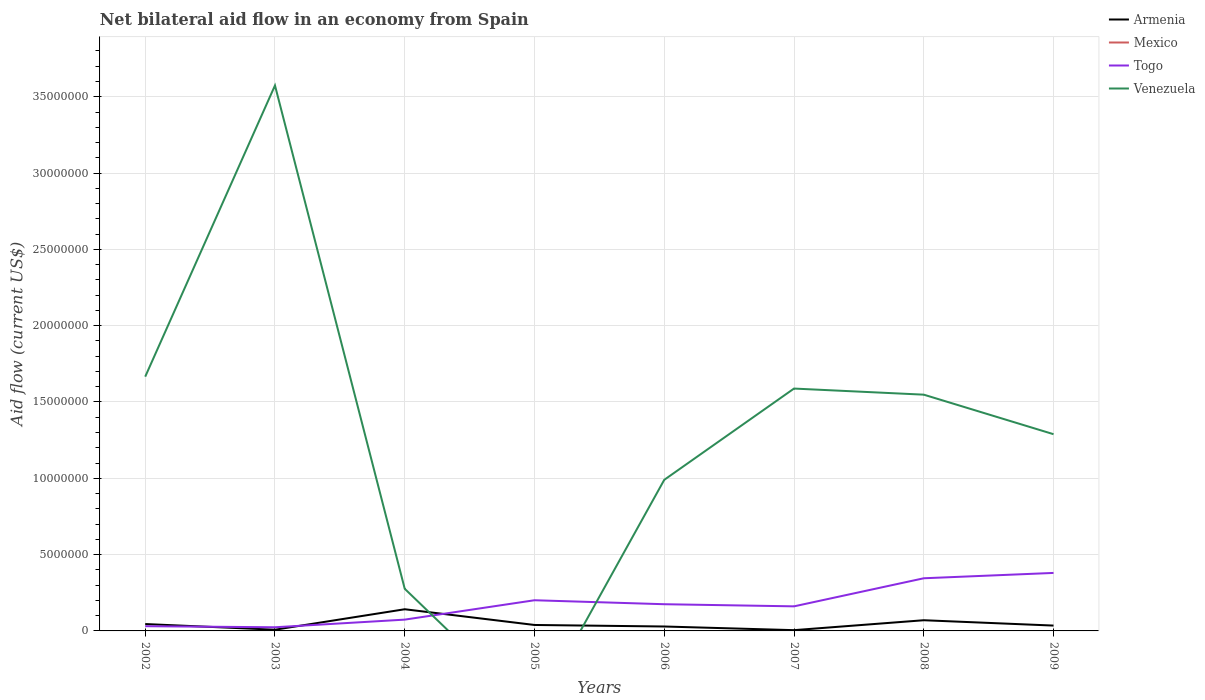Does the line corresponding to Togo intersect with the line corresponding to Venezuela?
Provide a short and direct response. Yes. Is the number of lines equal to the number of legend labels?
Offer a terse response. No. What is the total net bilateral aid flow in Togo in the graph?
Your answer should be compact. -2.71e+06. What is the difference between the highest and the second highest net bilateral aid flow in Armenia?
Ensure brevity in your answer.  1.37e+06. What is the difference between the highest and the lowest net bilateral aid flow in Togo?
Your response must be concise. 4. What is the difference between two consecutive major ticks on the Y-axis?
Provide a short and direct response. 5.00e+06. Where does the legend appear in the graph?
Your answer should be very brief. Top right. How many legend labels are there?
Offer a terse response. 4. How are the legend labels stacked?
Provide a short and direct response. Vertical. What is the title of the graph?
Offer a very short reply. Net bilateral aid flow in an economy from Spain. What is the label or title of the X-axis?
Give a very brief answer. Years. What is the label or title of the Y-axis?
Your answer should be compact. Aid flow (current US$). What is the Aid flow (current US$) in Armenia in 2002?
Make the answer very short. 4.50e+05. What is the Aid flow (current US$) of Mexico in 2002?
Offer a terse response. 0. What is the Aid flow (current US$) of Togo in 2002?
Provide a succinct answer. 3.10e+05. What is the Aid flow (current US$) of Venezuela in 2002?
Provide a short and direct response. 1.67e+07. What is the Aid flow (current US$) of Venezuela in 2003?
Offer a very short reply. 3.57e+07. What is the Aid flow (current US$) of Armenia in 2004?
Provide a succinct answer. 1.42e+06. What is the Aid flow (current US$) in Togo in 2004?
Provide a succinct answer. 7.40e+05. What is the Aid flow (current US$) of Venezuela in 2004?
Provide a succinct answer. 2.76e+06. What is the Aid flow (current US$) in Togo in 2005?
Provide a succinct answer. 2.01e+06. What is the Aid flow (current US$) of Venezuela in 2005?
Your answer should be very brief. 0. What is the Aid flow (current US$) in Armenia in 2006?
Provide a succinct answer. 2.90e+05. What is the Aid flow (current US$) in Togo in 2006?
Ensure brevity in your answer.  1.75e+06. What is the Aid flow (current US$) in Venezuela in 2006?
Your answer should be very brief. 9.90e+06. What is the Aid flow (current US$) of Armenia in 2007?
Keep it short and to the point. 5.00e+04. What is the Aid flow (current US$) of Mexico in 2007?
Your answer should be very brief. 0. What is the Aid flow (current US$) of Togo in 2007?
Provide a short and direct response. 1.61e+06. What is the Aid flow (current US$) of Venezuela in 2007?
Provide a succinct answer. 1.59e+07. What is the Aid flow (current US$) of Armenia in 2008?
Give a very brief answer. 7.00e+05. What is the Aid flow (current US$) of Togo in 2008?
Your response must be concise. 3.45e+06. What is the Aid flow (current US$) of Venezuela in 2008?
Keep it short and to the point. 1.55e+07. What is the Aid flow (current US$) in Armenia in 2009?
Provide a succinct answer. 3.50e+05. What is the Aid flow (current US$) of Mexico in 2009?
Your response must be concise. 0. What is the Aid flow (current US$) in Togo in 2009?
Keep it short and to the point. 3.80e+06. What is the Aid flow (current US$) of Venezuela in 2009?
Make the answer very short. 1.29e+07. Across all years, what is the maximum Aid flow (current US$) in Armenia?
Provide a short and direct response. 1.42e+06. Across all years, what is the maximum Aid flow (current US$) in Togo?
Your response must be concise. 3.80e+06. Across all years, what is the maximum Aid flow (current US$) in Venezuela?
Ensure brevity in your answer.  3.57e+07. Across all years, what is the minimum Aid flow (current US$) of Armenia?
Give a very brief answer. 5.00e+04. Across all years, what is the minimum Aid flow (current US$) of Togo?
Keep it short and to the point. 2.40e+05. What is the total Aid flow (current US$) of Armenia in the graph?
Provide a short and direct response. 3.73e+06. What is the total Aid flow (current US$) of Togo in the graph?
Ensure brevity in your answer.  1.39e+07. What is the total Aid flow (current US$) in Venezuela in the graph?
Your response must be concise. 1.09e+08. What is the difference between the Aid flow (current US$) in Armenia in 2002 and that in 2003?
Your answer should be compact. 3.70e+05. What is the difference between the Aid flow (current US$) of Venezuela in 2002 and that in 2003?
Your response must be concise. -1.91e+07. What is the difference between the Aid flow (current US$) of Armenia in 2002 and that in 2004?
Ensure brevity in your answer.  -9.70e+05. What is the difference between the Aid flow (current US$) of Togo in 2002 and that in 2004?
Provide a short and direct response. -4.30e+05. What is the difference between the Aid flow (current US$) of Venezuela in 2002 and that in 2004?
Give a very brief answer. 1.39e+07. What is the difference between the Aid flow (current US$) in Armenia in 2002 and that in 2005?
Offer a very short reply. 6.00e+04. What is the difference between the Aid flow (current US$) in Togo in 2002 and that in 2005?
Make the answer very short. -1.70e+06. What is the difference between the Aid flow (current US$) in Armenia in 2002 and that in 2006?
Your response must be concise. 1.60e+05. What is the difference between the Aid flow (current US$) of Togo in 2002 and that in 2006?
Ensure brevity in your answer.  -1.44e+06. What is the difference between the Aid flow (current US$) of Venezuela in 2002 and that in 2006?
Make the answer very short. 6.76e+06. What is the difference between the Aid flow (current US$) in Armenia in 2002 and that in 2007?
Provide a succinct answer. 4.00e+05. What is the difference between the Aid flow (current US$) of Togo in 2002 and that in 2007?
Provide a short and direct response. -1.30e+06. What is the difference between the Aid flow (current US$) of Venezuela in 2002 and that in 2007?
Offer a terse response. 7.80e+05. What is the difference between the Aid flow (current US$) of Armenia in 2002 and that in 2008?
Your answer should be very brief. -2.50e+05. What is the difference between the Aid flow (current US$) in Togo in 2002 and that in 2008?
Your answer should be very brief. -3.14e+06. What is the difference between the Aid flow (current US$) in Venezuela in 2002 and that in 2008?
Offer a terse response. 1.18e+06. What is the difference between the Aid flow (current US$) of Togo in 2002 and that in 2009?
Your answer should be compact. -3.49e+06. What is the difference between the Aid flow (current US$) of Venezuela in 2002 and that in 2009?
Provide a succinct answer. 3.77e+06. What is the difference between the Aid flow (current US$) in Armenia in 2003 and that in 2004?
Your answer should be very brief. -1.34e+06. What is the difference between the Aid flow (current US$) in Togo in 2003 and that in 2004?
Your answer should be very brief. -5.00e+05. What is the difference between the Aid flow (current US$) of Venezuela in 2003 and that in 2004?
Your response must be concise. 3.30e+07. What is the difference between the Aid flow (current US$) in Armenia in 2003 and that in 2005?
Offer a very short reply. -3.10e+05. What is the difference between the Aid flow (current US$) in Togo in 2003 and that in 2005?
Ensure brevity in your answer.  -1.77e+06. What is the difference between the Aid flow (current US$) in Togo in 2003 and that in 2006?
Your response must be concise. -1.51e+06. What is the difference between the Aid flow (current US$) in Venezuela in 2003 and that in 2006?
Your answer should be very brief. 2.58e+07. What is the difference between the Aid flow (current US$) in Togo in 2003 and that in 2007?
Your answer should be compact. -1.37e+06. What is the difference between the Aid flow (current US$) of Venezuela in 2003 and that in 2007?
Provide a short and direct response. 1.99e+07. What is the difference between the Aid flow (current US$) of Armenia in 2003 and that in 2008?
Your answer should be very brief. -6.20e+05. What is the difference between the Aid flow (current US$) of Togo in 2003 and that in 2008?
Give a very brief answer. -3.21e+06. What is the difference between the Aid flow (current US$) of Venezuela in 2003 and that in 2008?
Your answer should be very brief. 2.03e+07. What is the difference between the Aid flow (current US$) of Togo in 2003 and that in 2009?
Offer a terse response. -3.56e+06. What is the difference between the Aid flow (current US$) of Venezuela in 2003 and that in 2009?
Offer a terse response. 2.28e+07. What is the difference between the Aid flow (current US$) in Armenia in 2004 and that in 2005?
Your answer should be compact. 1.03e+06. What is the difference between the Aid flow (current US$) of Togo in 2004 and that in 2005?
Ensure brevity in your answer.  -1.27e+06. What is the difference between the Aid flow (current US$) of Armenia in 2004 and that in 2006?
Provide a succinct answer. 1.13e+06. What is the difference between the Aid flow (current US$) of Togo in 2004 and that in 2006?
Give a very brief answer. -1.01e+06. What is the difference between the Aid flow (current US$) in Venezuela in 2004 and that in 2006?
Make the answer very short. -7.14e+06. What is the difference between the Aid flow (current US$) of Armenia in 2004 and that in 2007?
Give a very brief answer. 1.37e+06. What is the difference between the Aid flow (current US$) in Togo in 2004 and that in 2007?
Provide a short and direct response. -8.70e+05. What is the difference between the Aid flow (current US$) in Venezuela in 2004 and that in 2007?
Your answer should be very brief. -1.31e+07. What is the difference between the Aid flow (current US$) in Armenia in 2004 and that in 2008?
Provide a succinct answer. 7.20e+05. What is the difference between the Aid flow (current US$) in Togo in 2004 and that in 2008?
Provide a succinct answer. -2.71e+06. What is the difference between the Aid flow (current US$) of Venezuela in 2004 and that in 2008?
Provide a succinct answer. -1.27e+07. What is the difference between the Aid flow (current US$) in Armenia in 2004 and that in 2009?
Offer a very short reply. 1.07e+06. What is the difference between the Aid flow (current US$) in Togo in 2004 and that in 2009?
Your answer should be compact. -3.06e+06. What is the difference between the Aid flow (current US$) of Venezuela in 2004 and that in 2009?
Keep it short and to the point. -1.01e+07. What is the difference between the Aid flow (current US$) in Togo in 2005 and that in 2006?
Give a very brief answer. 2.60e+05. What is the difference between the Aid flow (current US$) in Armenia in 2005 and that in 2007?
Your response must be concise. 3.40e+05. What is the difference between the Aid flow (current US$) in Armenia in 2005 and that in 2008?
Ensure brevity in your answer.  -3.10e+05. What is the difference between the Aid flow (current US$) in Togo in 2005 and that in 2008?
Offer a terse response. -1.44e+06. What is the difference between the Aid flow (current US$) of Togo in 2005 and that in 2009?
Your answer should be compact. -1.79e+06. What is the difference between the Aid flow (current US$) of Armenia in 2006 and that in 2007?
Offer a terse response. 2.40e+05. What is the difference between the Aid flow (current US$) in Venezuela in 2006 and that in 2007?
Provide a succinct answer. -5.98e+06. What is the difference between the Aid flow (current US$) in Armenia in 2006 and that in 2008?
Provide a short and direct response. -4.10e+05. What is the difference between the Aid flow (current US$) in Togo in 2006 and that in 2008?
Provide a succinct answer. -1.70e+06. What is the difference between the Aid flow (current US$) in Venezuela in 2006 and that in 2008?
Offer a terse response. -5.58e+06. What is the difference between the Aid flow (current US$) in Togo in 2006 and that in 2009?
Offer a very short reply. -2.05e+06. What is the difference between the Aid flow (current US$) in Venezuela in 2006 and that in 2009?
Make the answer very short. -2.99e+06. What is the difference between the Aid flow (current US$) in Armenia in 2007 and that in 2008?
Offer a very short reply. -6.50e+05. What is the difference between the Aid flow (current US$) in Togo in 2007 and that in 2008?
Your answer should be compact. -1.84e+06. What is the difference between the Aid flow (current US$) in Venezuela in 2007 and that in 2008?
Your answer should be compact. 4.00e+05. What is the difference between the Aid flow (current US$) of Armenia in 2007 and that in 2009?
Ensure brevity in your answer.  -3.00e+05. What is the difference between the Aid flow (current US$) of Togo in 2007 and that in 2009?
Your response must be concise. -2.19e+06. What is the difference between the Aid flow (current US$) of Venezuela in 2007 and that in 2009?
Your response must be concise. 2.99e+06. What is the difference between the Aid flow (current US$) in Togo in 2008 and that in 2009?
Ensure brevity in your answer.  -3.50e+05. What is the difference between the Aid flow (current US$) of Venezuela in 2008 and that in 2009?
Your answer should be compact. 2.59e+06. What is the difference between the Aid flow (current US$) of Armenia in 2002 and the Aid flow (current US$) of Venezuela in 2003?
Your answer should be compact. -3.53e+07. What is the difference between the Aid flow (current US$) in Togo in 2002 and the Aid flow (current US$) in Venezuela in 2003?
Keep it short and to the point. -3.54e+07. What is the difference between the Aid flow (current US$) in Armenia in 2002 and the Aid flow (current US$) in Venezuela in 2004?
Provide a short and direct response. -2.31e+06. What is the difference between the Aid flow (current US$) of Togo in 2002 and the Aid flow (current US$) of Venezuela in 2004?
Your answer should be compact. -2.45e+06. What is the difference between the Aid flow (current US$) in Armenia in 2002 and the Aid flow (current US$) in Togo in 2005?
Provide a short and direct response. -1.56e+06. What is the difference between the Aid flow (current US$) of Armenia in 2002 and the Aid flow (current US$) of Togo in 2006?
Ensure brevity in your answer.  -1.30e+06. What is the difference between the Aid flow (current US$) of Armenia in 2002 and the Aid flow (current US$) of Venezuela in 2006?
Offer a very short reply. -9.45e+06. What is the difference between the Aid flow (current US$) of Togo in 2002 and the Aid flow (current US$) of Venezuela in 2006?
Make the answer very short. -9.59e+06. What is the difference between the Aid flow (current US$) in Armenia in 2002 and the Aid flow (current US$) in Togo in 2007?
Provide a succinct answer. -1.16e+06. What is the difference between the Aid flow (current US$) in Armenia in 2002 and the Aid flow (current US$) in Venezuela in 2007?
Give a very brief answer. -1.54e+07. What is the difference between the Aid flow (current US$) of Togo in 2002 and the Aid flow (current US$) of Venezuela in 2007?
Ensure brevity in your answer.  -1.56e+07. What is the difference between the Aid flow (current US$) of Armenia in 2002 and the Aid flow (current US$) of Togo in 2008?
Offer a very short reply. -3.00e+06. What is the difference between the Aid flow (current US$) in Armenia in 2002 and the Aid flow (current US$) in Venezuela in 2008?
Your answer should be compact. -1.50e+07. What is the difference between the Aid flow (current US$) in Togo in 2002 and the Aid flow (current US$) in Venezuela in 2008?
Offer a very short reply. -1.52e+07. What is the difference between the Aid flow (current US$) of Armenia in 2002 and the Aid flow (current US$) of Togo in 2009?
Ensure brevity in your answer.  -3.35e+06. What is the difference between the Aid flow (current US$) in Armenia in 2002 and the Aid flow (current US$) in Venezuela in 2009?
Offer a terse response. -1.24e+07. What is the difference between the Aid flow (current US$) in Togo in 2002 and the Aid flow (current US$) in Venezuela in 2009?
Give a very brief answer. -1.26e+07. What is the difference between the Aid flow (current US$) in Armenia in 2003 and the Aid flow (current US$) in Togo in 2004?
Give a very brief answer. -6.60e+05. What is the difference between the Aid flow (current US$) of Armenia in 2003 and the Aid flow (current US$) of Venezuela in 2004?
Ensure brevity in your answer.  -2.68e+06. What is the difference between the Aid flow (current US$) in Togo in 2003 and the Aid flow (current US$) in Venezuela in 2004?
Keep it short and to the point. -2.52e+06. What is the difference between the Aid flow (current US$) in Armenia in 2003 and the Aid flow (current US$) in Togo in 2005?
Offer a terse response. -1.93e+06. What is the difference between the Aid flow (current US$) of Armenia in 2003 and the Aid flow (current US$) of Togo in 2006?
Your answer should be very brief. -1.67e+06. What is the difference between the Aid flow (current US$) in Armenia in 2003 and the Aid flow (current US$) in Venezuela in 2006?
Make the answer very short. -9.82e+06. What is the difference between the Aid flow (current US$) in Togo in 2003 and the Aid flow (current US$) in Venezuela in 2006?
Your response must be concise. -9.66e+06. What is the difference between the Aid flow (current US$) in Armenia in 2003 and the Aid flow (current US$) in Togo in 2007?
Give a very brief answer. -1.53e+06. What is the difference between the Aid flow (current US$) of Armenia in 2003 and the Aid flow (current US$) of Venezuela in 2007?
Offer a terse response. -1.58e+07. What is the difference between the Aid flow (current US$) in Togo in 2003 and the Aid flow (current US$) in Venezuela in 2007?
Make the answer very short. -1.56e+07. What is the difference between the Aid flow (current US$) of Armenia in 2003 and the Aid flow (current US$) of Togo in 2008?
Give a very brief answer. -3.37e+06. What is the difference between the Aid flow (current US$) of Armenia in 2003 and the Aid flow (current US$) of Venezuela in 2008?
Provide a succinct answer. -1.54e+07. What is the difference between the Aid flow (current US$) in Togo in 2003 and the Aid flow (current US$) in Venezuela in 2008?
Your response must be concise. -1.52e+07. What is the difference between the Aid flow (current US$) of Armenia in 2003 and the Aid flow (current US$) of Togo in 2009?
Your answer should be compact. -3.72e+06. What is the difference between the Aid flow (current US$) of Armenia in 2003 and the Aid flow (current US$) of Venezuela in 2009?
Offer a very short reply. -1.28e+07. What is the difference between the Aid flow (current US$) in Togo in 2003 and the Aid flow (current US$) in Venezuela in 2009?
Offer a terse response. -1.26e+07. What is the difference between the Aid flow (current US$) in Armenia in 2004 and the Aid flow (current US$) in Togo in 2005?
Give a very brief answer. -5.90e+05. What is the difference between the Aid flow (current US$) of Armenia in 2004 and the Aid flow (current US$) of Togo in 2006?
Your answer should be compact. -3.30e+05. What is the difference between the Aid flow (current US$) in Armenia in 2004 and the Aid flow (current US$) in Venezuela in 2006?
Keep it short and to the point. -8.48e+06. What is the difference between the Aid flow (current US$) of Togo in 2004 and the Aid flow (current US$) of Venezuela in 2006?
Provide a short and direct response. -9.16e+06. What is the difference between the Aid flow (current US$) in Armenia in 2004 and the Aid flow (current US$) in Togo in 2007?
Your answer should be compact. -1.90e+05. What is the difference between the Aid flow (current US$) in Armenia in 2004 and the Aid flow (current US$) in Venezuela in 2007?
Ensure brevity in your answer.  -1.45e+07. What is the difference between the Aid flow (current US$) in Togo in 2004 and the Aid flow (current US$) in Venezuela in 2007?
Offer a very short reply. -1.51e+07. What is the difference between the Aid flow (current US$) in Armenia in 2004 and the Aid flow (current US$) in Togo in 2008?
Ensure brevity in your answer.  -2.03e+06. What is the difference between the Aid flow (current US$) of Armenia in 2004 and the Aid flow (current US$) of Venezuela in 2008?
Offer a very short reply. -1.41e+07. What is the difference between the Aid flow (current US$) in Togo in 2004 and the Aid flow (current US$) in Venezuela in 2008?
Your answer should be compact. -1.47e+07. What is the difference between the Aid flow (current US$) in Armenia in 2004 and the Aid flow (current US$) in Togo in 2009?
Provide a short and direct response. -2.38e+06. What is the difference between the Aid flow (current US$) of Armenia in 2004 and the Aid flow (current US$) of Venezuela in 2009?
Keep it short and to the point. -1.15e+07. What is the difference between the Aid flow (current US$) in Togo in 2004 and the Aid flow (current US$) in Venezuela in 2009?
Your answer should be very brief. -1.22e+07. What is the difference between the Aid flow (current US$) in Armenia in 2005 and the Aid flow (current US$) in Togo in 2006?
Ensure brevity in your answer.  -1.36e+06. What is the difference between the Aid flow (current US$) of Armenia in 2005 and the Aid flow (current US$) of Venezuela in 2006?
Give a very brief answer. -9.51e+06. What is the difference between the Aid flow (current US$) in Togo in 2005 and the Aid flow (current US$) in Venezuela in 2006?
Provide a short and direct response. -7.89e+06. What is the difference between the Aid flow (current US$) of Armenia in 2005 and the Aid flow (current US$) of Togo in 2007?
Ensure brevity in your answer.  -1.22e+06. What is the difference between the Aid flow (current US$) in Armenia in 2005 and the Aid flow (current US$) in Venezuela in 2007?
Offer a terse response. -1.55e+07. What is the difference between the Aid flow (current US$) of Togo in 2005 and the Aid flow (current US$) of Venezuela in 2007?
Make the answer very short. -1.39e+07. What is the difference between the Aid flow (current US$) of Armenia in 2005 and the Aid flow (current US$) of Togo in 2008?
Your answer should be compact. -3.06e+06. What is the difference between the Aid flow (current US$) of Armenia in 2005 and the Aid flow (current US$) of Venezuela in 2008?
Your answer should be compact. -1.51e+07. What is the difference between the Aid flow (current US$) in Togo in 2005 and the Aid flow (current US$) in Venezuela in 2008?
Your answer should be very brief. -1.35e+07. What is the difference between the Aid flow (current US$) in Armenia in 2005 and the Aid flow (current US$) in Togo in 2009?
Keep it short and to the point. -3.41e+06. What is the difference between the Aid flow (current US$) of Armenia in 2005 and the Aid flow (current US$) of Venezuela in 2009?
Your response must be concise. -1.25e+07. What is the difference between the Aid flow (current US$) of Togo in 2005 and the Aid flow (current US$) of Venezuela in 2009?
Provide a short and direct response. -1.09e+07. What is the difference between the Aid flow (current US$) in Armenia in 2006 and the Aid flow (current US$) in Togo in 2007?
Offer a very short reply. -1.32e+06. What is the difference between the Aid flow (current US$) in Armenia in 2006 and the Aid flow (current US$) in Venezuela in 2007?
Your response must be concise. -1.56e+07. What is the difference between the Aid flow (current US$) of Togo in 2006 and the Aid flow (current US$) of Venezuela in 2007?
Provide a succinct answer. -1.41e+07. What is the difference between the Aid flow (current US$) of Armenia in 2006 and the Aid flow (current US$) of Togo in 2008?
Provide a succinct answer. -3.16e+06. What is the difference between the Aid flow (current US$) in Armenia in 2006 and the Aid flow (current US$) in Venezuela in 2008?
Provide a short and direct response. -1.52e+07. What is the difference between the Aid flow (current US$) of Togo in 2006 and the Aid flow (current US$) of Venezuela in 2008?
Keep it short and to the point. -1.37e+07. What is the difference between the Aid flow (current US$) in Armenia in 2006 and the Aid flow (current US$) in Togo in 2009?
Provide a short and direct response. -3.51e+06. What is the difference between the Aid flow (current US$) of Armenia in 2006 and the Aid flow (current US$) of Venezuela in 2009?
Provide a short and direct response. -1.26e+07. What is the difference between the Aid flow (current US$) in Togo in 2006 and the Aid flow (current US$) in Venezuela in 2009?
Your answer should be compact. -1.11e+07. What is the difference between the Aid flow (current US$) of Armenia in 2007 and the Aid flow (current US$) of Togo in 2008?
Your response must be concise. -3.40e+06. What is the difference between the Aid flow (current US$) of Armenia in 2007 and the Aid flow (current US$) of Venezuela in 2008?
Make the answer very short. -1.54e+07. What is the difference between the Aid flow (current US$) in Togo in 2007 and the Aid flow (current US$) in Venezuela in 2008?
Give a very brief answer. -1.39e+07. What is the difference between the Aid flow (current US$) of Armenia in 2007 and the Aid flow (current US$) of Togo in 2009?
Ensure brevity in your answer.  -3.75e+06. What is the difference between the Aid flow (current US$) of Armenia in 2007 and the Aid flow (current US$) of Venezuela in 2009?
Offer a very short reply. -1.28e+07. What is the difference between the Aid flow (current US$) in Togo in 2007 and the Aid flow (current US$) in Venezuela in 2009?
Ensure brevity in your answer.  -1.13e+07. What is the difference between the Aid flow (current US$) in Armenia in 2008 and the Aid flow (current US$) in Togo in 2009?
Your answer should be compact. -3.10e+06. What is the difference between the Aid flow (current US$) in Armenia in 2008 and the Aid flow (current US$) in Venezuela in 2009?
Offer a very short reply. -1.22e+07. What is the difference between the Aid flow (current US$) in Togo in 2008 and the Aid flow (current US$) in Venezuela in 2009?
Your answer should be very brief. -9.44e+06. What is the average Aid flow (current US$) of Armenia per year?
Your response must be concise. 4.66e+05. What is the average Aid flow (current US$) in Mexico per year?
Your response must be concise. 0. What is the average Aid flow (current US$) of Togo per year?
Provide a succinct answer. 1.74e+06. What is the average Aid flow (current US$) of Venezuela per year?
Offer a very short reply. 1.37e+07. In the year 2002, what is the difference between the Aid flow (current US$) in Armenia and Aid flow (current US$) in Togo?
Provide a short and direct response. 1.40e+05. In the year 2002, what is the difference between the Aid flow (current US$) in Armenia and Aid flow (current US$) in Venezuela?
Give a very brief answer. -1.62e+07. In the year 2002, what is the difference between the Aid flow (current US$) of Togo and Aid flow (current US$) of Venezuela?
Provide a short and direct response. -1.64e+07. In the year 2003, what is the difference between the Aid flow (current US$) of Armenia and Aid flow (current US$) of Venezuela?
Your answer should be compact. -3.57e+07. In the year 2003, what is the difference between the Aid flow (current US$) in Togo and Aid flow (current US$) in Venezuela?
Your answer should be compact. -3.55e+07. In the year 2004, what is the difference between the Aid flow (current US$) in Armenia and Aid flow (current US$) in Togo?
Provide a succinct answer. 6.80e+05. In the year 2004, what is the difference between the Aid flow (current US$) of Armenia and Aid flow (current US$) of Venezuela?
Provide a short and direct response. -1.34e+06. In the year 2004, what is the difference between the Aid flow (current US$) of Togo and Aid flow (current US$) of Venezuela?
Offer a terse response. -2.02e+06. In the year 2005, what is the difference between the Aid flow (current US$) in Armenia and Aid flow (current US$) in Togo?
Your response must be concise. -1.62e+06. In the year 2006, what is the difference between the Aid flow (current US$) in Armenia and Aid flow (current US$) in Togo?
Your answer should be compact. -1.46e+06. In the year 2006, what is the difference between the Aid flow (current US$) of Armenia and Aid flow (current US$) of Venezuela?
Offer a terse response. -9.61e+06. In the year 2006, what is the difference between the Aid flow (current US$) in Togo and Aid flow (current US$) in Venezuela?
Offer a terse response. -8.15e+06. In the year 2007, what is the difference between the Aid flow (current US$) of Armenia and Aid flow (current US$) of Togo?
Make the answer very short. -1.56e+06. In the year 2007, what is the difference between the Aid flow (current US$) of Armenia and Aid flow (current US$) of Venezuela?
Keep it short and to the point. -1.58e+07. In the year 2007, what is the difference between the Aid flow (current US$) of Togo and Aid flow (current US$) of Venezuela?
Your answer should be compact. -1.43e+07. In the year 2008, what is the difference between the Aid flow (current US$) of Armenia and Aid flow (current US$) of Togo?
Your answer should be compact. -2.75e+06. In the year 2008, what is the difference between the Aid flow (current US$) in Armenia and Aid flow (current US$) in Venezuela?
Make the answer very short. -1.48e+07. In the year 2008, what is the difference between the Aid flow (current US$) in Togo and Aid flow (current US$) in Venezuela?
Your response must be concise. -1.20e+07. In the year 2009, what is the difference between the Aid flow (current US$) of Armenia and Aid flow (current US$) of Togo?
Give a very brief answer. -3.45e+06. In the year 2009, what is the difference between the Aid flow (current US$) in Armenia and Aid flow (current US$) in Venezuela?
Your answer should be compact. -1.25e+07. In the year 2009, what is the difference between the Aid flow (current US$) of Togo and Aid flow (current US$) of Venezuela?
Your answer should be compact. -9.09e+06. What is the ratio of the Aid flow (current US$) of Armenia in 2002 to that in 2003?
Your response must be concise. 5.62. What is the ratio of the Aid flow (current US$) of Togo in 2002 to that in 2003?
Ensure brevity in your answer.  1.29. What is the ratio of the Aid flow (current US$) in Venezuela in 2002 to that in 2003?
Offer a very short reply. 0.47. What is the ratio of the Aid flow (current US$) of Armenia in 2002 to that in 2004?
Make the answer very short. 0.32. What is the ratio of the Aid flow (current US$) of Togo in 2002 to that in 2004?
Offer a very short reply. 0.42. What is the ratio of the Aid flow (current US$) of Venezuela in 2002 to that in 2004?
Give a very brief answer. 6.04. What is the ratio of the Aid flow (current US$) in Armenia in 2002 to that in 2005?
Provide a short and direct response. 1.15. What is the ratio of the Aid flow (current US$) of Togo in 2002 to that in 2005?
Ensure brevity in your answer.  0.15. What is the ratio of the Aid flow (current US$) of Armenia in 2002 to that in 2006?
Keep it short and to the point. 1.55. What is the ratio of the Aid flow (current US$) in Togo in 2002 to that in 2006?
Provide a short and direct response. 0.18. What is the ratio of the Aid flow (current US$) of Venezuela in 2002 to that in 2006?
Provide a succinct answer. 1.68. What is the ratio of the Aid flow (current US$) in Armenia in 2002 to that in 2007?
Give a very brief answer. 9. What is the ratio of the Aid flow (current US$) of Togo in 2002 to that in 2007?
Provide a succinct answer. 0.19. What is the ratio of the Aid flow (current US$) in Venezuela in 2002 to that in 2007?
Ensure brevity in your answer.  1.05. What is the ratio of the Aid flow (current US$) in Armenia in 2002 to that in 2008?
Ensure brevity in your answer.  0.64. What is the ratio of the Aid flow (current US$) in Togo in 2002 to that in 2008?
Your answer should be very brief. 0.09. What is the ratio of the Aid flow (current US$) in Venezuela in 2002 to that in 2008?
Give a very brief answer. 1.08. What is the ratio of the Aid flow (current US$) in Togo in 2002 to that in 2009?
Offer a very short reply. 0.08. What is the ratio of the Aid flow (current US$) in Venezuela in 2002 to that in 2009?
Offer a terse response. 1.29. What is the ratio of the Aid flow (current US$) of Armenia in 2003 to that in 2004?
Keep it short and to the point. 0.06. What is the ratio of the Aid flow (current US$) of Togo in 2003 to that in 2004?
Offer a very short reply. 0.32. What is the ratio of the Aid flow (current US$) in Venezuela in 2003 to that in 2004?
Make the answer very short. 12.95. What is the ratio of the Aid flow (current US$) of Armenia in 2003 to that in 2005?
Make the answer very short. 0.21. What is the ratio of the Aid flow (current US$) in Togo in 2003 to that in 2005?
Your answer should be compact. 0.12. What is the ratio of the Aid flow (current US$) in Armenia in 2003 to that in 2006?
Provide a short and direct response. 0.28. What is the ratio of the Aid flow (current US$) in Togo in 2003 to that in 2006?
Your answer should be compact. 0.14. What is the ratio of the Aid flow (current US$) of Venezuela in 2003 to that in 2006?
Your answer should be compact. 3.61. What is the ratio of the Aid flow (current US$) in Armenia in 2003 to that in 2007?
Give a very brief answer. 1.6. What is the ratio of the Aid flow (current US$) in Togo in 2003 to that in 2007?
Offer a very short reply. 0.15. What is the ratio of the Aid flow (current US$) in Venezuela in 2003 to that in 2007?
Provide a short and direct response. 2.25. What is the ratio of the Aid flow (current US$) of Armenia in 2003 to that in 2008?
Provide a short and direct response. 0.11. What is the ratio of the Aid flow (current US$) of Togo in 2003 to that in 2008?
Ensure brevity in your answer.  0.07. What is the ratio of the Aid flow (current US$) of Venezuela in 2003 to that in 2008?
Your answer should be very brief. 2.31. What is the ratio of the Aid flow (current US$) in Armenia in 2003 to that in 2009?
Your answer should be compact. 0.23. What is the ratio of the Aid flow (current US$) of Togo in 2003 to that in 2009?
Provide a succinct answer. 0.06. What is the ratio of the Aid flow (current US$) in Venezuela in 2003 to that in 2009?
Keep it short and to the point. 2.77. What is the ratio of the Aid flow (current US$) of Armenia in 2004 to that in 2005?
Provide a short and direct response. 3.64. What is the ratio of the Aid flow (current US$) in Togo in 2004 to that in 2005?
Ensure brevity in your answer.  0.37. What is the ratio of the Aid flow (current US$) in Armenia in 2004 to that in 2006?
Your response must be concise. 4.9. What is the ratio of the Aid flow (current US$) of Togo in 2004 to that in 2006?
Provide a succinct answer. 0.42. What is the ratio of the Aid flow (current US$) in Venezuela in 2004 to that in 2006?
Offer a very short reply. 0.28. What is the ratio of the Aid flow (current US$) of Armenia in 2004 to that in 2007?
Your response must be concise. 28.4. What is the ratio of the Aid flow (current US$) in Togo in 2004 to that in 2007?
Ensure brevity in your answer.  0.46. What is the ratio of the Aid flow (current US$) in Venezuela in 2004 to that in 2007?
Provide a succinct answer. 0.17. What is the ratio of the Aid flow (current US$) in Armenia in 2004 to that in 2008?
Your answer should be very brief. 2.03. What is the ratio of the Aid flow (current US$) in Togo in 2004 to that in 2008?
Your answer should be very brief. 0.21. What is the ratio of the Aid flow (current US$) of Venezuela in 2004 to that in 2008?
Ensure brevity in your answer.  0.18. What is the ratio of the Aid flow (current US$) in Armenia in 2004 to that in 2009?
Your response must be concise. 4.06. What is the ratio of the Aid flow (current US$) in Togo in 2004 to that in 2009?
Offer a terse response. 0.19. What is the ratio of the Aid flow (current US$) in Venezuela in 2004 to that in 2009?
Give a very brief answer. 0.21. What is the ratio of the Aid flow (current US$) in Armenia in 2005 to that in 2006?
Offer a terse response. 1.34. What is the ratio of the Aid flow (current US$) of Togo in 2005 to that in 2006?
Offer a very short reply. 1.15. What is the ratio of the Aid flow (current US$) in Togo in 2005 to that in 2007?
Offer a terse response. 1.25. What is the ratio of the Aid flow (current US$) of Armenia in 2005 to that in 2008?
Give a very brief answer. 0.56. What is the ratio of the Aid flow (current US$) of Togo in 2005 to that in 2008?
Your response must be concise. 0.58. What is the ratio of the Aid flow (current US$) in Armenia in 2005 to that in 2009?
Your answer should be very brief. 1.11. What is the ratio of the Aid flow (current US$) of Togo in 2005 to that in 2009?
Ensure brevity in your answer.  0.53. What is the ratio of the Aid flow (current US$) of Togo in 2006 to that in 2007?
Ensure brevity in your answer.  1.09. What is the ratio of the Aid flow (current US$) of Venezuela in 2006 to that in 2007?
Your answer should be very brief. 0.62. What is the ratio of the Aid flow (current US$) of Armenia in 2006 to that in 2008?
Offer a very short reply. 0.41. What is the ratio of the Aid flow (current US$) in Togo in 2006 to that in 2008?
Provide a short and direct response. 0.51. What is the ratio of the Aid flow (current US$) of Venezuela in 2006 to that in 2008?
Your response must be concise. 0.64. What is the ratio of the Aid flow (current US$) in Armenia in 2006 to that in 2009?
Give a very brief answer. 0.83. What is the ratio of the Aid flow (current US$) in Togo in 2006 to that in 2009?
Provide a succinct answer. 0.46. What is the ratio of the Aid flow (current US$) in Venezuela in 2006 to that in 2009?
Offer a terse response. 0.77. What is the ratio of the Aid flow (current US$) of Armenia in 2007 to that in 2008?
Your answer should be compact. 0.07. What is the ratio of the Aid flow (current US$) in Togo in 2007 to that in 2008?
Give a very brief answer. 0.47. What is the ratio of the Aid flow (current US$) in Venezuela in 2007 to that in 2008?
Your response must be concise. 1.03. What is the ratio of the Aid flow (current US$) in Armenia in 2007 to that in 2009?
Provide a short and direct response. 0.14. What is the ratio of the Aid flow (current US$) in Togo in 2007 to that in 2009?
Keep it short and to the point. 0.42. What is the ratio of the Aid flow (current US$) of Venezuela in 2007 to that in 2009?
Make the answer very short. 1.23. What is the ratio of the Aid flow (current US$) in Togo in 2008 to that in 2009?
Your answer should be very brief. 0.91. What is the ratio of the Aid flow (current US$) in Venezuela in 2008 to that in 2009?
Ensure brevity in your answer.  1.2. What is the difference between the highest and the second highest Aid flow (current US$) of Armenia?
Provide a succinct answer. 7.20e+05. What is the difference between the highest and the second highest Aid flow (current US$) in Togo?
Offer a terse response. 3.50e+05. What is the difference between the highest and the second highest Aid flow (current US$) of Venezuela?
Your answer should be compact. 1.91e+07. What is the difference between the highest and the lowest Aid flow (current US$) of Armenia?
Give a very brief answer. 1.37e+06. What is the difference between the highest and the lowest Aid flow (current US$) in Togo?
Give a very brief answer. 3.56e+06. What is the difference between the highest and the lowest Aid flow (current US$) of Venezuela?
Give a very brief answer. 3.57e+07. 